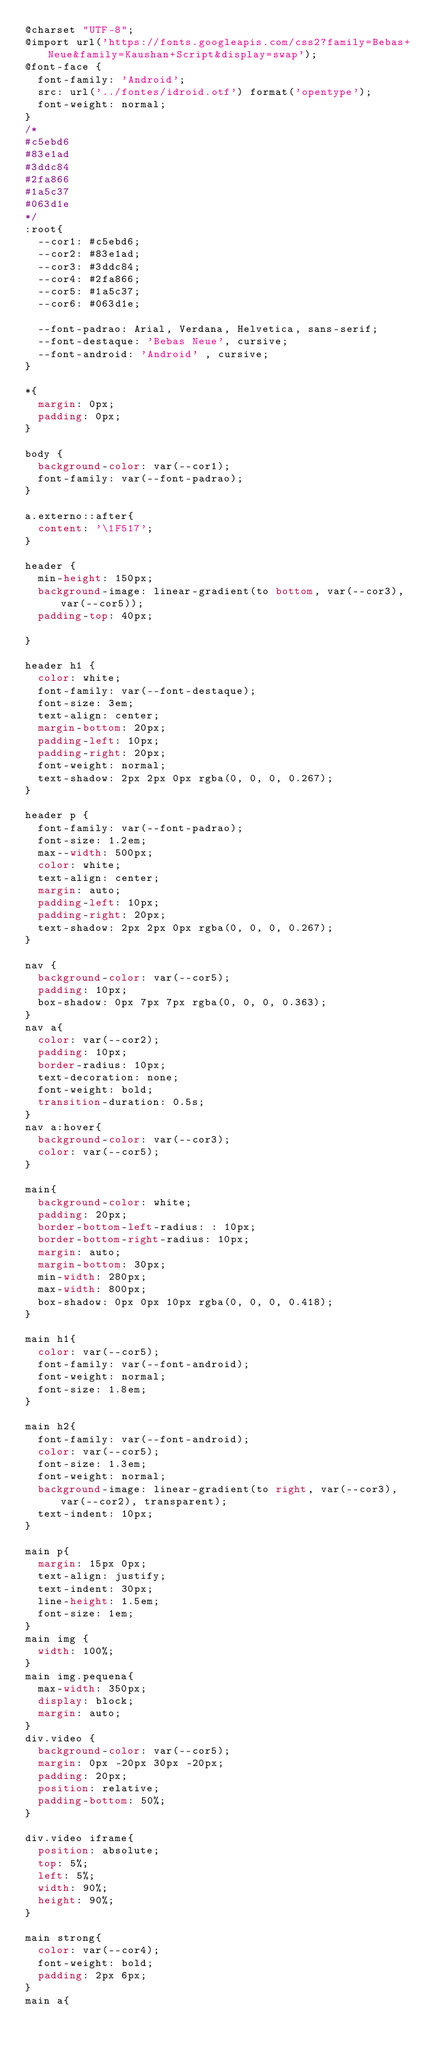Convert code to text. <code><loc_0><loc_0><loc_500><loc_500><_CSS_>@charset "UTF-8";
@import url('https://fonts.googleapis.com/css2?family=Bebas+Neue&family=Kaushan+Script&display=swap');
@font-face {
  font-family: 'Android';
  src: url('../fontes/idroid.otf') format('opentype');
  font-weight: normal;
}
/*
#c5ebd6
#83e1ad
#3ddc84
#2fa866
#1a5c37
#063d1e
*/
:root{
  --cor1: #c5ebd6;
  --cor2: #83e1ad;
  --cor3: #3ddc84;
  --cor4: #2fa866;
  --cor5: #1a5c37;
  --cor6: #063d1e;

  --font-padrao: Arial, Verdana, Helvetica, sans-serif;
  --font-destaque: 'Bebas Neue', cursive;
  --font-android: 'Android' , cursive;
}

*{
  margin: 0px;
  padding: 0px;
}

body {
  background-color: var(--cor1);
  font-family: var(--font-padrao);
}

a.externo::after{
  content: '\1F517';
}

header {
  min-height: 150px;
  background-image: linear-gradient(to bottom, var(--cor3), var(--cor5));
  padding-top: 40px;

}

header h1 {
  color: white;
  font-family: var(--font-destaque);
  font-size: 3em;
  text-align: center;
  margin-bottom: 20px;
  padding-left: 10px;
  padding-right: 20px;
  font-weight: normal;
  text-shadow: 2px 2px 0px rgba(0, 0, 0, 0.267);
}

header p {
  font-family: var(--font-padrao);
  font-size: 1.2em;
  max--width: 500px;
  color: white;
  text-align: center;
  margin: auto;
  padding-left: 10px;
  padding-right: 20px;
  text-shadow: 2px 2px 0px rgba(0, 0, 0, 0.267);
}

nav {
  background-color: var(--cor5);
  padding: 10px;
  box-shadow: 0px 7px 7px rgba(0, 0, 0, 0.363);
}
nav a{
  color: var(--cor2);
  padding: 10px;
  border-radius: 10px;
  text-decoration: none;
  font-weight: bold;
  transition-duration: 0.5s;
}
nav a:hover{
  background-color: var(--cor3);
  color: var(--cor5);
}

main{
  background-color: white;
  padding: 20px;
  border-bottom-left-radius: : 10px;
  border-bottom-right-radius: 10px;
  margin: auto;
  margin-bottom: 30px;
  min-width: 280px;
  max-width: 800px;
  box-shadow: 0px 0px 10px rgba(0, 0, 0, 0.418);
}

main h1{
  color: var(--cor5);
  font-family: var(--font-android);
  font-weight: normal;
  font-size: 1.8em;
}

main h2{
  font-family: var(--font-android);
  color: var(--cor5);
  font-size: 1.3em;
  font-weight: normal;
  background-image: linear-gradient(to right, var(--cor3), var(--cor2), transparent);
  text-indent: 10px;
}

main p{
  margin: 15px 0px;
  text-align: justify;
  text-indent: 30px;
  line-height: 1.5em;
  font-size: 1em;
}
main img {
  width: 100%;
}
main img.pequena{
  max-width: 350px;
  display: block;
  margin: auto;
}
div.video {
  background-color: var(--cor5);
  margin: 0px -20px 30px -20px;
  padding: 20px;
  position: relative;
  padding-bottom: 50%;
}

div.video iframe{
  position: absolute;
  top: 5%;
  left: 5%;
  width: 90%;
  height: 90%;
}

main strong{
  color: var(--cor4);
  font-weight: bold;
  padding: 2px 6px;
}
main a{</code> 